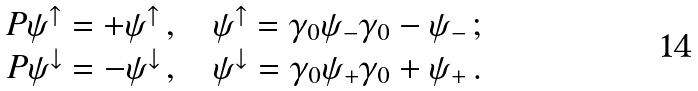Convert formula to latex. <formula><loc_0><loc_0><loc_500><loc_500>\begin{array} { c } P \psi ^ { \uparrow } = + \psi ^ { \uparrow } \, , \quad \psi ^ { \uparrow } = \gamma _ { 0 } \psi _ { - } \gamma _ { 0 } - \psi _ { - } \, ; \\ P \psi ^ { \downarrow } = - \psi ^ { \downarrow } \, , \quad \psi ^ { \downarrow } = \gamma _ { 0 } \psi _ { + } \gamma _ { 0 } + \psi _ { + } \, . \end{array}</formula> 